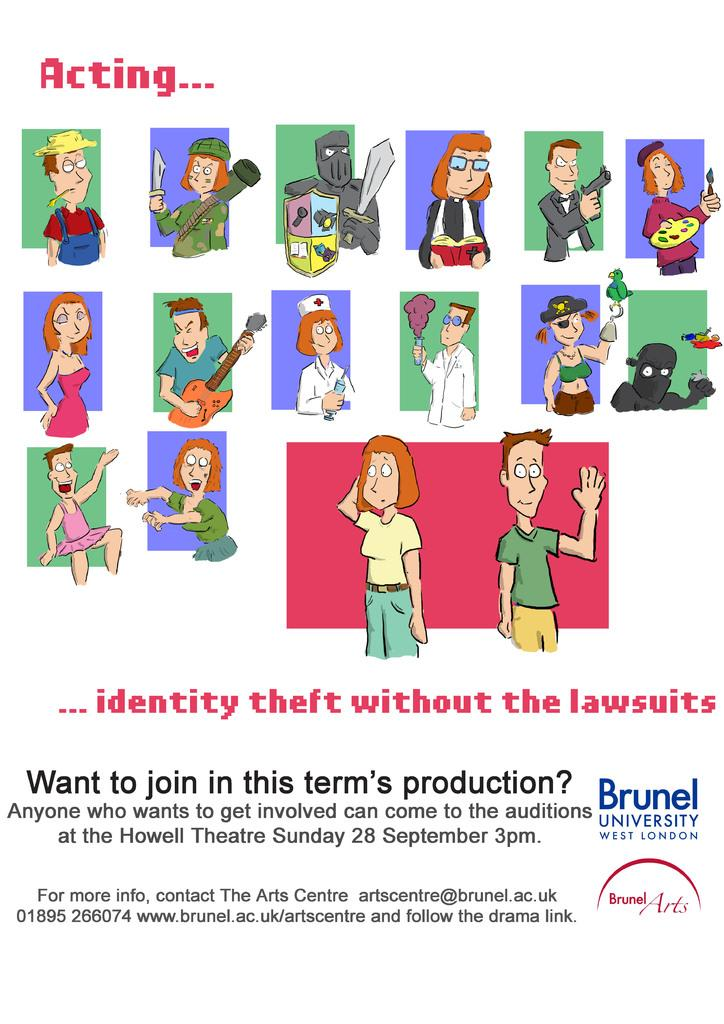What is depicted on the poster in the image? There is a poster with cartoon characters in the image. What else can be seen on the poster besides the cartoon characters? There is writing on the poster. What flavor of air can be tasted in the image? There is no mention of air or flavor in the image, so it cannot be determined from the image. 